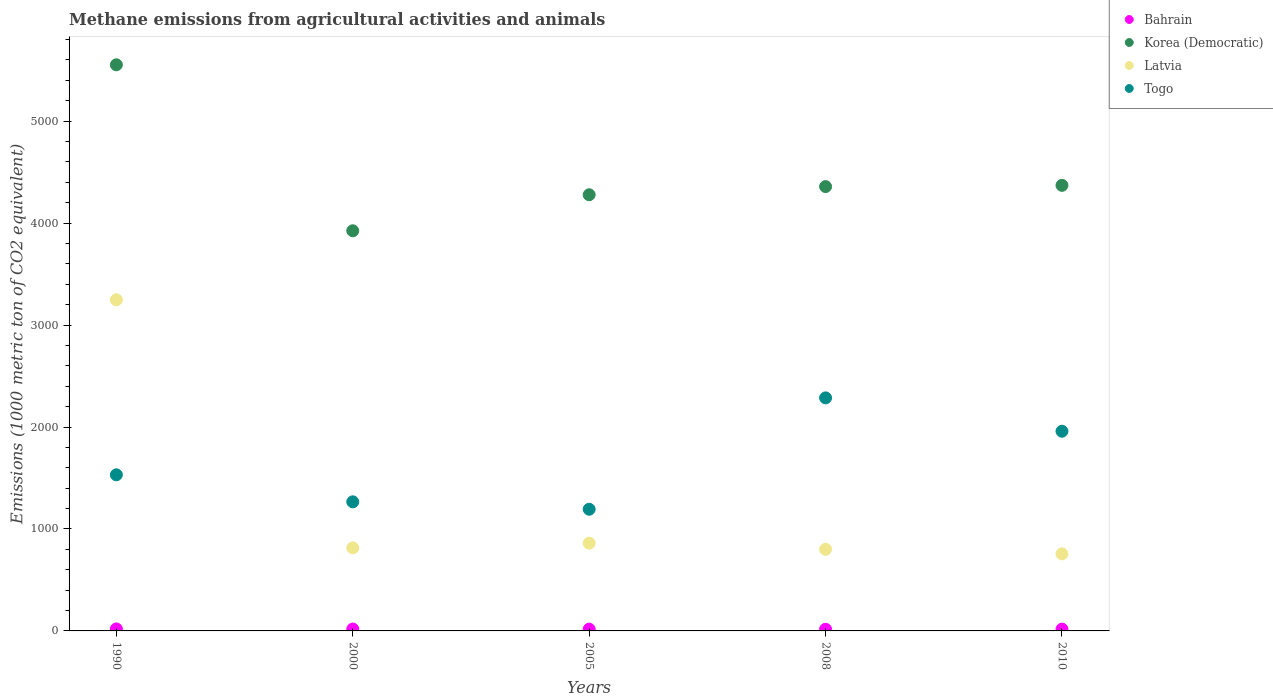How many different coloured dotlines are there?
Your answer should be compact. 4. What is the amount of methane emitted in Togo in 2005?
Offer a very short reply. 1193.3. Across all years, what is the maximum amount of methane emitted in Bahrain?
Make the answer very short. 19.5. Across all years, what is the minimum amount of methane emitted in Togo?
Ensure brevity in your answer.  1193.3. In which year was the amount of methane emitted in Bahrain maximum?
Offer a terse response. 1990. What is the total amount of methane emitted in Togo in the graph?
Your answer should be compact. 8234.7. What is the difference between the amount of methane emitted in Latvia in 1990 and that in 2000?
Provide a succinct answer. 2433.3. What is the difference between the amount of methane emitted in Latvia in 2008 and the amount of methane emitted in Togo in 2010?
Provide a short and direct response. -1157.7. What is the average amount of methane emitted in Togo per year?
Provide a short and direct response. 1646.94. In the year 2010, what is the difference between the amount of methane emitted in Latvia and amount of methane emitted in Togo?
Ensure brevity in your answer.  -1202.6. In how many years, is the amount of methane emitted in Togo greater than 4000 1000 metric ton?
Make the answer very short. 0. What is the ratio of the amount of methane emitted in Korea (Democratic) in 2000 to that in 2005?
Make the answer very short. 0.92. Is the amount of methane emitted in Korea (Democratic) in 2000 less than that in 2008?
Offer a very short reply. Yes. Is the difference between the amount of methane emitted in Latvia in 1990 and 2000 greater than the difference between the amount of methane emitted in Togo in 1990 and 2000?
Your response must be concise. Yes. What is the difference between the highest and the second highest amount of methane emitted in Latvia?
Make the answer very short. 2387.1. What is the difference between the highest and the lowest amount of methane emitted in Bahrain?
Make the answer very short. 3.3. Is the sum of the amount of methane emitted in Korea (Democratic) in 1990 and 2000 greater than the maximum amount of methane emitted in Bahrain across all years?
Offer a terse response. Yes. Does the amount of methane emitted in Korea (Democratic) monotonically increase over the years?
Offer a terse response. No. Is the amount of methane emitted in Togo strictly greater than the amount of methane emitted in Korea (Democratic) over the years?
Your answer should be compact. No. Is the amount of methane emitted in Togo strictly less than the amount of methane emitted in Bahrain over the years?
Provide a succinct answer. No. How many years are there in the graph?
Keep it short and to the point. 5. What is the difference between two consecutive major ticks on the Y-axis?
Your response must be concise. 1000. Does the graph contain any zero values?
Keep it short and to the point. No. Where does the legend appear in the graph?
Your answer should be very brief. Top right. How many legend labels are there?
Offer a very short reply. 4. What is the title of the graph?
Provide a succinct answer. Methane emissions from agricultural activities and animals. What is the label or title of the Y-axis?
Keep it short and to the point. Emissions (1000 metric ton of CO2 equivalent). What is the Emissions (1000 metric ton of CO2 equivalent) of Korea (Democratic) in 1990?
Keep it short and to the point. 5552.4. What is the Emissions (1000 metric ton of CO2 equivalent) of Latvia in 1990?
Keep it short and to the point. 3247.8. What is the Emissions (1000 metric ton of CO2 equivalent) of Togo in 1990?
Keep it short and to the point. 1531.1. What is the Emissions (1000 metric ton of CO2 equivalent) in Korea (Democratic) in 2000?
Provide a short and direct response. 3924.5. What is the Emissions (1000 metric ton of CO2 equivalent) of Latvia in 2000?
Make the answer very short. 814.5. What is the Emissions (1000 metric ton of CO2 equivalent) in Togo in 2000?
Your answer should be very brief. 1266.2. What is the Emissions (1000 metric ton of CO2 equivalent) in Bahrain in 2005?
Provide a succinct answer. 17.5. What is the Emissions (1000 metric ton of CO2 equivalent) of Korea (Democratic) in 2005?
Make the answer very short. 4277.9. What is the Emissions (1000 metric ton of CO2 equivalent) in Latvia in 2005?
Provide a short and direct response. 860.7. What is the Emissions (1000 metric ton of CO2 equivalent) in Togo in 2005?
Offer a terse response. 1193.3. What is the Emissions (1000 metric ton of CO2 equivalent) in Korea (Democratic) in 2008?
Offer a terse response. 4357.8. What is the Emissions (1000 metric ton of CO2 equivalent) in Latvia in 2008?
Keep it short and to the point. 800.8. What is the Emissions (1000 metric ton of CO2 equivalent) of Togo in 2008?
Offer a very short reply. 2285.6. What is the Emissions (1000 metric ton of CO2 equivalent) in Korea (Democratic) in 2010?
Keep it short and to the point. 4370.1. What is the Emissions (1000 metric ton of CO2 equivalent) in Latvia in 2010?
Ensure brevity in your answer.  755.9. What is the Emissions (1000 metric ton of CO2 equivalent) of Togo in 2010?
Ensure brevity in your answer.  1958.5. Across all years, what is the maximum Emissions (1000 metric ton of CO2 equivalent) of Bahrain?
Your answer should be very brief. 19.5. Across all years, what is the maximum Emissions (1000 metric ton of CO2 equivalent) of Korea (Democratic)?
Your answer should be very brief. 5552.4. Across all years, what is the maximum Emissions (1000 metric ton of CO2 equivalent) of Latvia?
Make the answer very short. 3247.8. Across all years, what is the maximum Emissions (1000 metric ton of CO2 equivalent) of Togo?
Provide a succinct answer. 2285.6. Across all years, what is the minimum Emissions (1000 metric ton of CO2 equivalent) of Bahrain?
Your answer should be compact. 16.2. Across all years, what is the minimum Emissions (1000 metric ton of CO2 equivalent) of Korea (Democratic)?
Your response must be concise. 3924.5. Across all years, what is the minimum Emissions (1000 metric ton of CO2 equivalent) of Latvia?
Offer a terse response. 755.9. Across all years, what is the minimum Emissions (1000 metric ton of CO2 equivalent) of Togo?
Provide a succinct answer. 1193.3. What is the total Emissions (1000 metric ton of CO2 equivalent) of Bahrain in the graph?
Offer a very short reply. 89.4. What is the total Emissions (1000 metric ton of CO2 equivalent) in Korea (Democratic) in the graph?
Your response must be concise. 2.25e+04. What is the total Emissions (1000 metric ton of CO2 equivalent) of Latvia in the graph?
Make the answer very short. 6479.7. What is the total Emissions (1000 metric ton of CO2 equivalent) of Togo in the graph?
Provide a succinct answer. 8234.7. What is the difference between the Emissions (1000 metric ton of CO2 equivalent) of Korea (Democratic) in 1990 and that in 2000?
Keep it short and to the point. 1627.9. What is the difference between the Emissions (1000 metric ton of CO2 equivalent) of Latvia in 1990 and that in 2000?
Your answer should be very brief. 2433.3. What is the difference between the Emissions (1000 metric ton of CO2 equivalent) of Togo in 1990 and that in 2000?
Ensure brevity in your answer.  264.9. What is the difference between the Emissions (1000 metric ton of CO2 equivalent) in Bahrain in 1990 and that in 2005?
Ensure brevity in your answer.  2. What is the difference between the Emissions (1000 metric ton of CO2 equivalent) of Korea (Democratic) in 1990 and that in 2005?
Your response must be concise. 1274.5. What is the difference between the Emissions (1000 metric ton of CO2 equivalent) in Latvia in 1990 and that in 2005?
Your answer should be compact. 2387.1. What is the difference between the Emissions (1000 metric ton of CO2 equivalent) in Togo in 1990 and that in 2005?
Your answer should be very brief. 337.8. What is the difference between the Emissions (1000 metric ton of CO2 equivalent) in Korea (Democratic) in 1990 and that in 2008?
Give a very brief answer. 1194.6. What is the difference between the Emissions (1000 metric ton of CO2 equivalent) of Latvia in 1990 and that in 2008?
Keep it short and to the point. 2447. What is the difference between the Emissions (1000 metric ton of CO2 equivalent) in Togo in 1990 and that in 2008?
Offer a very short reply. -754.5. What is the difference between the Emissions (1000 metric ton of CO2 equivalent) in Bahrain in 1990 and that in 2010?
Keep it short and to the point. 1.8. What is the difference between the Emissions (1000 metric ton of CO2 equivalent) in Korea (Democratic) in 1990 and that in 2010?
Your answer should be compact. 1182.3. What is the difference between the Emissions (1000 metric ton of CO2 equivalent) in Latvia in 1990 and that in 2010?
Keep it short and to the point. 2491.9. What is the difference between the Emissions (1000 metric ton of CO2 equivalent) of Togo in 1990 and that in 2010?
Your answer should be very brief. -427.4. What is the difference between the Emissions (1000 metric ton of CO2 equivalent) in Korea (Democratic) in 2000 and that in 2005?
Your answer should be very brief. -353.4. What is the difference between the Emissions (1000 metric ton of CO2 equivalent) in Latvia in 2000 and that in 2005?
Give a very brief answer. -46.2. What is the difference between the Emissions (1000 metric ton of CO2 equivalent) in Togo in 2000 and that in 2005?
Your answer should be very brief. 72.9. What is the difference between the Emissions (1000 metric ton of CO2 equivalent) of Bahrain in 2000 and that in 2008?
Provide a short and direct response. 2.3. What is the difference between the Emissions (1000 metric ton of CO2 equivalent) of Korea (Democratic) in 2000 and that in 2008?
Provide a succinct answer. -433.3. What is the difference between the Emissions (1000 metric ton of CO2 equivalent) in Togo in 2000 and that in 2008?
Offer a terse response. -1019.4. What is the difference between the Emissions (1000 metric ton of CO2 equivalent) of Bahrain in 2000 and that in 2010?
Ensure brevity in your answer.  0.8. What is the difference between the Emissions (1000 metric ton of CO2 equivalent) in Korea (Democratic) in 2000 and that in 2010?
Keep it short and to the point. -445.6. What is the difference between the Emissions (1000 metric ton of CO2 equivalent) of Latvia in 2000 and that in 2010?
Keep it short and to the point. 58.6. What is the difference between the Emissions (1000 metric ton of CO2 equivalent) in Togo in 2000 and that in 2010?
Keep it short and to the point. -692.3. What is the difference between the Emissions (1000 metric ton of CO2 equivalent) of Korea (Democratic) in 2005 and that in 2008?
Ensure brevity in your answer.  -79.9. What is the difference between the Emissions (1000 metric ton of CO2 equivalent) in Latvia in 2005 and that in 2008?
Your answer should be very brief. 59.9. What is the difference between the Emissions (1000 metric ton of CO2 equivalent) of Togo in 2005 and that in 2008?
Your answer should be compact. -1092.3. What is the difference between the Emissions (1000 metric ton of CO2 equivalent) in Bahrain in 2005 and that in 2010?
Your answer should be very brief. -0.2. What is the difference between the Emissions (1000 metric ton of CO2 equivalent) in Korea (Democratic) in 2005 and that in 2010?
Give a very brief answer. -92.2. What is the difference between the Emissions (1000 metric ton of CO2 equivalent) of Latvia in 2005 and that in 2010?
Give a very brief answer. 104.8. What is the difference between the Emissions (1000 metric ton of CO2 equivalent) of Togo in 2005 and that in 2010?
Provide a short and direct response. -765.2. What is the difference between the Emissions (1000 metric ton of CO2 equivalent) of Korea (Democratic) in 2008 and that in 2010?
Give a very brief answer. -12.3. What is the difference between the Emissions (1000 metric ton of CO2 equivalent) of Latvia in 2008 and that in 2010?
Offer a terse response. 44.9. What is the difference between the Emissions (1000 metric ton of CO2 equivalent) in Togo in 2008 and that in 2010?
Ensure brevity in your answer.  327.1. What is the difference between the Emissions (1000 metric ton of CO2 equivalent) of Bahrain in 1990 and the Emissions (1000 metric ton of CO2 equivalent) of Korea (Democratic) in 2000?
Ensure brevity in your answer.  -3905. What is the difference between the Emissions (1000 metric ton of CO2 equivalent) of Bahrain in 1990 and the Emissions (1000 metric ton of CO2 equivalent) of Latvia in 2000?
Make the answer very short. -795. What is the difference between the Emissions (1000 metric ton of CO2 equivalent) in Bahrain in 1990 and the Emissions (1000 metric ton of CO2 equivalent) in Togo in 2000?
Ensure brevity in your answer.  -1246.7. What is the difference between the Emissions (1000 metric ton of CO2 equivalent) in Korea (Democratic) in 1990 and the Emissions (1000 metric ton of CO2 equivalent) in Latvia in 2000?
Give a very brief answer. 4737.9. What is the difference between the Emissions (1000 metric ton of CO2 equivalent) of Korea (Democratic) in 1990 and the Emissions (1000 metric ton of CO2 equivalent) of Togo in 2000?
Keep it short and to the point. 4286.2. What is the difference between the Emissions (1000 metric ton of CO2 equivalent) in Latvia in 1990 and the Emissions (1000 metric ton of CO2 equivalent) in Togo in 2000?
Provide a short and direct response. 1981.6. What is the difference between the Emissions (1000 metric ton of CO2 equivalent) of Bahrain in 1990 and the Emissions (1000 metric ton of CO2 equivalent) of Korea (Democratic) in 2005?
Provide a succinct answer. -4258.4. What is the difference between the Emissions (1000 metric ton of CO2 equivalent) in Bahrain in 1990 and the Emissions (1000 metric ton of CO2 equivalent) in Latvia in 2005?
Your response must be concise. -841.2. What is the difference between the Emissions (1000 metric ton of CO2 equivalent) of Bahrain in 1990 and the Emissions (1000 metric ton of CO2 equivalent) of Togo in 2005?
Your answer should be very brief. -1173.8. What is the difference between the Emissions (1000 metric ton of CO2 equivalent) of Korea (Democratic) in 1990 and the Emissions (1000 metric ton of CO2 equivalent) of Latvia in 2005?
Your response must be concise. 4691.7. What is the difference between the Emissions (1000 metric ton of CO2 equivalent) of Korea (Democratic) in 1990 and the Emissions (1000 metric ton of CO2 equivalent) of Togo in 2005?
Provide a short and direct response. 4359.1. What is the difference between the Emissions (1000 metric ton of CO2 equivalent) in Latvia in 1990 and the Emissions (1000 metric ton of CO2 equivalent) in Togo in 2005?
Give a very brief answer. 2054.5. What is the difference between the Emissions (1000 metric ton of CO2 equivalent) in Bahrain in 1990 and the Emissions (1000 metric ton of CO2 equivalent) in Korea (Democratic) in 2008?
Your response must be concise. -4338.3. What is the difference between the Emissions (1000 metric ton of CO2 equivalent) in Bahrain in 1990 and the Emissions (1000 metric ton of CO2 equivalent) in Latvia in 2008?
Your answer should be compact. -781.3. What is the difference between the Emissions (1000 metric ton of CO2 equivalent) in Bahrain in 1990 and the Emissions (1000 metric ton of CO2 equivalent) in Togo in 2008?
Your answer should be very brief. -2266.1. What is the difference between the Emissions (1000 metric ton of CO2 equivalent) in Korea (Democratic) in 1990 and the Emissions (1000 metric ton of CO2 equivalent) in Latvia in 2008?
Ensure brevity in your answer.  4751.6. What is the difference between the Emissions (1000 metric ton of CO2 equivalent) of Korea (Democratic) in 1990 and the Emissions (1000 metric ton of CO2 equivalent) of Togo in 2008?
Provide a short and direct response. 3266.8. What is the difference between the Emissions (1000 metric ton of CO2 equivalent) of Latvia in 1990 and the Emissions (1000 metric ton of CO2 equivalent) of Togo in 2008?
Give a very brief answer. 962.2. What is the difference between the Emissions (1000 metric ton of CO2 equivalent) of Bahrain in 1990 and the Emissions (1000 metric ton of CO2 equivalent) of Korea (Democratic) in 2010?
Provide a succinct answer. -4350.6. What is the difference between the Emissions (1000 metric ton of CO2 equivalent) in Bahrain in 1990 and the Emissions (1000 metric ton of CO2 equivalent) in Latvia in 2010?
Provide a short and direct response. -736.4. What is the difference between the Emissions (1000 metric ton of CO2 equivalent) in Bahrain in 1990 and the Emissions (1000 metric ton of CO2 equivalent) in Togo in 2010?
Keep it short and to the point. -1939. What is the difference between the Emissions (1000 metric ton of CO2 equivalent) of Korea (Democratic) in 1990 and the Emissions (1000 metric ton of CO2 equivalent) of Latvia in 2010?
Your answer should be very brief. 4796.5. What is the difference between the Emissions (1000 metric ton of CO2 equivalent) of Korea (Democratic) in 1990 and the Emissions (1000 metric ton of CO2 equivalent) of Togo in 2010?
Make the answer very short. 3593.9. What is the difference between the Emissions (1000 metric ton of CO2 equivalent) of Latvia in 1990 and the Emissions (1000 metric ton of CO2 equivalent) of Togo in 2010?
Offer a very short reply. 1289.3. What is the difference between the Emissions (1000 metric ton of CO2 equivalent) in Bahrain in 2000 and the Emissions (1000 metric ton of CO2 equivalent) in Korea (Democratic) in 2005?
Provide a short and direct response. -4259.4. What is the difference between the Emissions (1000 metric ton of CO2 equivalent) of Bahrain in 2000 and the Emissions (1000 metric ton of CO2 equivalent) of Latvia in 2005?
Your response must be concise. -842.2. What is the difference between the Emissions (1000 metric ton of CO2 equivalent) of Bahrain in 2000 and the Emissions (1000 metric ton of CO2 equivalent) of Togo in 2005?
Ensure brevity in your answer.  -1174.8. What is the difference between the Emissions (1000 metric ton of CO2 equivalent) in Korea (Democratic) in 2000 and the Emissions (1000 metric ton of CO2 equivalent) in Latvia in 2005?
Ensure brevity in your answer.  3063.8. What is the difference between the Emissions (1000 metric ton of CO2 equivalent) in Korea (Democratic) in 2000 and the Emissions (1000 metric ton of CO2 equivalent) in Togo in 2005?
Offer a very short reply. 2731.2. What is the difference between the Emissions (1000 metric ton of CO2 equivalent) of Latvia in 2000 and the Emissions (1000 metric ton of CO2 equivalent) of Togo in 2005?
Offer a very short reply. -378.8. What is the difference between the Emissions (1000 metric ton of CO2 equivalent) of Bahrain in 2000 and the Emissions (1000 metric ton of CO2 equivalent) of Korea (Democratic) in 2008?
Provide a succinct answer. -4339.3. What is the difference between the Emissions (1000 metric ton of CO2 equivalent) of Bahrain in 2000 and the Emissions (1000 metric ton of CO2 equivalent) of Latvia in 2008?
Provide a succinct answer. -782.3. What is the difference between the Emissions (1000 metric ton of CO2 equivalent) of Bahrain in 2000 and the Emissions (1000 metric ton of CO2 equivalent) of Togo in 2008?
Give a very brief answer. -2267.1. What is the difference between the Emissions (1000 metric ton of CO2 equivalent) in Korea (Democratic) in 2000 and the Emissions (1000 metric ton of CO2 equivalent) in Latvia in 2008?
Make the answer very short. 3123.7. What is the difference between the Emissions (1000 metric ton of CO2 equivalent) in Korea (Democratic) in 2000 and the Emissions (1000 metric ton of CO2 equivalent) in Togo in 2008?
Give a very brief answer. 1638.9. What is the difference between the Emissions (1000 metric ton of CO2 equivalent) of Latvia in 2000 and the Emissions (1000 metric ton of CO2 equivalent) of Togo in 2008?
Your answer should be compact. -1471.1. What is the difference between the Emissions (1000 metric ton of CO2 equivalent) of Bahrain in 2000 and the Emissions (1000 metric ton of CO2 equivalent) of Korea (Democratic) in 2010?
Make the answer very short. -4351.6. What is the difference between the Emissions (1000 metric ton of CO2 equivalent) in Bahrain in 2000 and the Emissions (1000 metric ton of CO2 equivalent) in Latvia in 2010?
Offer a very short reply. -737.4. What is the difference between the Emissions (1000 metric ton of CO2 equivalent) in Bahrain in 2000 and the Emissions (1000 metric ton of CO2 equivalent) in Togo in 2010?
Your response must be concise. -1940. What is the difference between the Emissions (1000 metric ton of CO2 equivalent) of Korea (Democratic) in 2000 and the Emissions (1000 metric ton of CO2 equivalent) of Latvia in 2010?
Your response must be concise. 3168.6. What is the difference between the Emissions (1000 metric ton of CO2 equivalent) of Korea (Democratic) in 2000 and the Emissions (1000 metric ton of CO2 equivalent) of Togo in 2010?
Keep it short and to the point. 1966. What is the difference between the Emissions (1000 metric ton of CO2 equivalent) in Latvia in 2000 and the Emissions (1000 metric ton of CO2 equivalent) in Togo in 2010?
Give a very brief answer. -1144. What is the difference between the Emissions (1000 metric ton of CO2 equivalent) in Bahrain in 2005 and the Emissions (1000 metric ton of CO2 equivalent) in Korea (Democratic) in 2008?
Your answer should be very brief. -4340.3. What is the difference between the Emissions (1000 metric ton of CO2 equivalent) of Bahrain in 2005 and the Emissions (1000 metric ton of CO2 equivalent) of Latvia in 2008?
Provide a short and direct response. -783.3. What is the difference between the Emissions (1000 metric ton of CO2 equivalent) of Bahrain in 2005 and the Emissions (1000 metric ton of CO2 equivalent) of Togo in 2008?
Offer a very short reply. -2268.1. What is the difference between the Emissions (1000 metric ton of CO2 equivalent) of Korea (Democratic) in 2005 and the Emissions (1000 metric ton of CO2 equivalent) of Latvia in 2008?
Provide a succinct answer. 3477.1. What is the difference between the Emissions (1000 metric ton of CO2 equivalent) in Korea (Democratic) in 2005 and the Emissions (1000 metric ton of CO2 equivalent) in Togo in 2008?
Make the answer very short. 1992.3. What is the difference between the Emissions (1000 metric ton of CO2 equivalent) in Latvia in 2005 and the Emissions (1000 metric ton of CO2 equivalent) in Togo in 2008?
Your answer should be compact. -1424.9. What is the difference between the Emissions (1000 metric ton of CO2 equivalent) in Bahrain in 2005 and the Emissions (1000 metric ton of CO2 equivalent) in Korea (Democratic) in 2010?
Provide a short and direct response. -4352.6. What is the difference between the Emissions (1000 metric ton of CO2 equivalent) of Bahrain in 2005 and the Emissions (1000 metric ton of CO2 equivalent) of Latvia in 2010?
Your response must be concise. -738.4. What is the difference between the Emissions (1000 metric ton of CO2 equivalent) of Bahrain in 2005 and the Emissions (1000 metric ton of CO2 equivalent) of Togo in 2010?
Your answer should be compact. -1941. What is the difference between the Emissions (1000 metric ton of CO2 equivalent) of Korea (Democratic) in 2005 and the Emissions (1000 metric ton of CO2 equivalent) of Latvia in 2010?
Your answer should be compact. 3522. What is the difference between the Emissions (1000 metric ton of CO2 equivalent) in Korea (Democratic) in 2005 and the Emissions (1000 metric ton of CO2 equivalent) in Togo in 2010?
Provide a short and direct response. 2319.4. What is the difference between the Emissions (1000 metric ton of CO2 equivalent) in Latvia in 2005 and the Emissions (1000 metric ton of CO2 equivalent) in Togo in 2010?
Ensure brevity in your answer.  -1097.8. What is the difference between the Emissions (1000 metric ton of CO2 equivalent) of Bahrain in 2008 and the Emissions (1000 metric ton of CO2 equivalent) of Korea (Democratic) in 2010?
Your answer should be very brief. -4353.9. What is the difference between the Emissions (1000 metric ton of CO2 equivalent) of Bahrain in 2008 and the Emissions (1000 metric ton of CO2 equivalent) of Latvia in 2010?
Your response must be concise. -739.7. What is the difference between the Emissions (1000 metric ton of CO2 equivalent) in Bahrain in 2008 and the Emissions (1000 metric ton of CO2 equivalent) in Togo in 2010?
Offer a terse response. -1942.3. What is the difference between the Emissions (1000 metric ton of CO2 equivalent) of Korea (Democratic) in 2008 and the Emissions (1000 metric ton of CO2 equivalent) of Latvia in 2010?
Provide a succinct answer. 3601.9. What is the difference between the Emissions (1000 metric ton of CO2 equivalent) of Korea (Democratic) in 2008 and the Emissions (1000 metric ton of CO2 equivalent) of Togo in 2010?
Ensure brevity in your answer.  2399.3. What is the difference between the Emissions (1000 metric ton of CO2 equivalent) in Latvia in 2008 and the Emissions (1000 metric ton of CO2 equivalent) in Togo in 2010?
Make the answer very short. -1157.7. What is the average Emissions (1000 metric ton of CO2 equivalent) in Bahrain per year?
Offer a terse response. 17.88. What is the average Emissions (1000 metric ton of CO2 equivalent) of Korea (Democratic) per year?
Offer a very short reply. 4496.54. What is the average Emissions (1000 metric ton of CO2 equivalent) of Latvia per year?
Make the answer very short. 1295.94. What is the average Emissions (1000 metric ton of CO2 equivalent) of Togo per year?
Your answer should be very brief. 1646.94. In the year 1990, what is the difference between the Emissions (1000 metric ton of CO2 equivalent) of Bahrain and Emissions (1000 metric ton of CO2 equivalent) of Korea (Democratic)?
Ensure brevity in your answer.  -5532.9. In the year 1990, what is the difference between the Emissions (1000 metric ton of CO2 equivalent) of Bahrain and Emissions (1000 metric ton of CO2 equivalent) of Latvia?
Ensure brevity in your answer.  -3228.3. In the year 1990, what is the difference between the Emissions (1000 metric ton of CO2 equivalent) in Bahrain and Emissions (1000 metric ton of CO2 equivalent) in Togo?
Offer a terse response. -1511.6. In the year 1990, what is the difference between the Emissions (1000 metric ton of CO2 equivalent) of Korea (Democratic) and Emissions (1000 metric ton of CO2 equivalent) of Latvia?
Provide a short and direct response. 2304.6. In the year 1990, what is the difference between the Emissions (1000 metric ton of CO2 equivalent) of Korea (Democratic) and Emissions (1000 metric ton of CO2 equivalent) of Togo?
Provide a short and direct response. 4021.3. In the year 1990, what is the difference between the Emissions (1000 metric ton of CO2 equivalent) of Latvia and Emissions (1000 metric ton of CO2 equivalent) of Togo?
Keep it short and to the point. 1716.7. In the year 2000, what is the difference between the Emissions (1000 metric ton of CO2 equivalent) in Bahrain and Emissions (1000 metric ton of CO2 equivalent) in Korea (Democratic)?
Offer a terse response. -3906. In the year 2000, what is the difference between the Emissions (1000 metric ton of CO2 equivalent) of Bahrain and Emissions (1000 metric ton of CO2 equivalent) of Latvia?
Provide a succinct answer. -796. In the year 2000, what is the difference between the Emissions (1000 metric ton of CO2 equivalent) of Bahrain and Emissions (1000 metric ton of CO2 equivalent) of Togo?
Keep it short and to the point. -1247.7. In the year 2000, what is the difference between the Emissions (1000 metric ton of CO2 equivalent) of Korea (Democratic) and Emissions (1000 metric ton of CO2 equivalent) of Latvia?
Offer a terse response. 3110. In the year 2000, what is the difference between the Emissions (1000 metric ton of CO2 equivalent) in Korea (Democratic) and Emissions (1000 metric ton of CO2 equivalent) in Togo?
Make the answer very short. 2658.3. In the year 2000, what is the difference between the Emissions (1000 metric ton of CO2 equivalent) of Latvia and Emissions (1000 metric ton of CO2 equivalent) of Togo?
Ensure brevity in your answer.  -451.7. In the year 2005, what is the difference between the Emissions (1000 metric ton of CO2 equivalent) of Bahrain and Emissions (1000 metric ton of CO2 equivalent) of Korea (Democratic)?
Offer a terse response. -4260.4. In the year 2005, what is the difference between the Emissions (1000 metric ton of CO2 equivalent) of Bahrain and Emissions (1000 metric ton of CO2 equivalent) of Latvia?
Offer a terse response. -843.2. In the year 2005, what is the difference between the Emissions (1000 metric ton of CO2 equivalent) in Bahrain and Emissions (1000 metric ton of CO2 equivalent) in Togo?
Offer a very short reply. -1175.8. In the year 2005, what is the difference between the Emissions (1000 metric ton of CO2 equivalent) of Korea (Democratic) and Emissions (1000 metric ton of CO2 equivalent) of Latvia?
Provide a short and direct response. 3417.2. In the year 2005, what is the difference between the Emissions (1000 metric ton of CO2 equivalent) in Korea (Democratic) and Emissions (1000 metric ton of CO2 equivalent) in Togo?
Your answer should be compact. 3084.6. In the year 2005, what is the difference between the Emissions (1000 metric ton of CO2 equivalent) of Latvia and Emissions (1000 metric ton of CO2 equivalent) of Togo?
Provide a short and direct response. -332.6. In the year 2008, what is the difference between the Emissions (1000 metric ton of CO2 equivalent) in Bahrain and Emissions (1000 metric ton of CO2 equivalent) in Korea (Democratic)?
Provide a short and direct response. -4341.6. In the year 2008, what is the difference between the Emissions (1000 metric ton of CO2 equivalent) of Bahrain and Emissions (1000 metric ton of CO2 equivalent) of Latvia?
Keep it short and to the point. -784.6. In the year 2008, what is the difference between the Emissions (1000 metric ton of CO2 equivalent) in Bahrain and Emissions (1000 metric ton of CO2 equivalent) in Togo?
Provide a short and direct response. -2269.4. In the year 2008, what is the difference between the Emissions (1000 metric ton of CO2 equivalent) in Korea (Democratic) and Emissions (1000 metric ton of CO2 equivalent) in Latvia?
Your response must be concise. 3557. In the year 2008, what is the difference between the Emissions (1000 metric ton of CO2 equivalent) in Korea (Democratic) and Emissions (1000 metric ton of CO2 equivalent) in Togo?
Offer a very short reply. 2072.2. In the year 2008, what is the difference between the Emissions (1000 metric ton of CO2 equivalent) of Latvia and Emissions (1000 metric ton of CO2 equivalent) of Togo?
Your response must be concise. -1484.8. In the year 2010, what is the difference between the Emissions (1000 metric ton of CO2 equivalent) in Bahrain and Emissions (1000 metric ton of CO2 equivalent) in Korea (Democratic)?
Your response must be concise. -4352.4. In the year 2010, what is the difference between the Emissions (1000 metric ton of CO2 equivalent) of Bahrain and Emissions (1000 metric ton of CO2 equivalent) of Latvia?
Offer a very short reply. -738.2. In the year 2010, what is the difference between the Emissions (1000 metric ton of CO2 equivalent) in Bahrain and Emissions (1000 metric ton of CO2 equivalent) in Togo?
Your answer should be very brief. -1940.8. In the year 2010, what is the difference between the Emissions (1000 metric ton of CO2 equivalent) of Korea (Democratic) and Emissions (1000 metric ton of CO2 equivalent) of Latvia?
Provide a succinct answer. 3614.2. In the year 2010, what is the difference between the Emissions (1000 metric ton of CO2 equivalent) in Korea (Democratic) and Emissions (1000 metric ton of CO2 equivalent) in Togo?
Offer a terse response. 2411.6. In the year 2010, what is the difference between the Emissions (1000 metric ton of CO2 equivalent) of Latvia and Emissions (1000 metric ton of CO2 equivalent) of Togo?
Make the answer very short. -1202.6. What is the ratio of the Emissions (1000 metric ton of CO2 equivalent) of Bahrain in 1990 to that in 2000?
Offer a very short reply. 1.05. What is the ratio of the Emissions (1000 metric ton of CO2 equivalent) in Korea (Democratic) in 1990 to that in 2000?
Keep it short and to the point. 1.41. What is the ratio of the Emissions (1000 metric ton of CO2 equivalent) of Latvia in 1990 to that in 2000?
Provide a succinct answer. 3.99. What is the ratio of the Emissions (1000 metric ton of CO2 equivalent) in Togo in 1990 to that in 2000?
Give a very brief answer. 1.21. What is the ratio of the Emissions (1000 metric ton of CO2 equivalent) in Bahrain in 1990 to that in 2005?
Give a very brief answer. 1.11. What is the ratio of the Emissions (1000 metric ton of CO2 equivalent) of Korea (Democratic) in 1990 to that in 2005?
Make the answer very short. 1.3. What is the ratio of the Emissions (1000 metric ton of CO2 equivalent) of Latvia in 1990 to that in 2005?
Make the answer very short. 3.77. What is the ratio of the Emissions (1000 metric ton of CO2 equivalent) in Togo in 1990 to that in 2005?
Ensure brevity in your answer.  1.28. What is the ratio of the Emissions (1000 metric ton of CO2 equivalent) of Bahrain in 1990 to that in 2008?
Make the answer very short. 1.2. What is the ratio of the Emissions (1000 metric ton of CO2 equivalent) of Korea (Democratic) in 1990 to that in 2008?
Provide a succinct answer. 1.27. What is the ratio of the Emissions (1000 metric ton of CO2 equivalent) in Latvia in 1990 to that in 2008?
Keep it short and to the point. 4.06. What is the ratio of the Emissions (1000 metric ton of CO2 equivalent) of Togo in 1990 to that in 2008?
Your answer should be very brief. 0.67. What is the ratio of the Emissions (1000 metric ton of CO2 equivalent) in Bahrain in 1990 to that in 2010?
Your response must be concise. 1.1. What is the ratio of the Emissions (1000 metric ton of CO2 equivalent) in Korea (Democratic) in 1990 to that in 2010?
Your response must be concise. 1.27. What is the ratio of the Emissions (1000 metric ton of CO2 equivalent) of Latvia in 1990 to that in 2010?
Give a very brief answer. 4.3. What is the ratio of the Emissions (1000 metric ton of CO2 equivalent) of Togo in 1990 to that in 2010?
Provide a short and direct response. 0.78. What is the ratio of the Emissions (1000 metric ton of CO2 equivalent) in Bahrain in 2000 to that in 2005?
Provide a succinct answer. 1.06. What is the ratio of the Emissions (1000 metric ton of CO2 equivalent) of Korea (Democratic) in 2000 to that in 2005?
Keep it short and to the point. 0.92. What is the ratio of the Emissions (1000 metric ton of CO2 equivalent) in Latvia in 2000 to that in 2005?
Provide a succinct answer. 0.95. What is the ratio of the Emissions (1000 metric ton of CO2 equivalent) of Togo in 2000 to that in 2005?
Your response must be concise. 1.06. What is the ratio of the Emissions (1000 metric ton of CO2 equivalent) in Bahrain in 2000 to that in 2008?
Keep it short and to the point. 1.14. What is the ratio of the Emissions (1000 metric ton of CO2 equivalent) of Korea (Democratic) in 2000 to that in 2008?
Keep it short and to the point. 0.9. What is the ratio of the Emissions (1000 metric ton of CO2 equivalent) of Latvia in 2000 to that in 2008?
Offer a very short reply. 1.02. What is the ratio of the Emissions (1000 metric ton of CO2 equivalent) in Togo in 2000 to that in 2008?
Provide a succinct answer. 0.55. What is the ratio of the Emissions (1000 metric ton of CO2 equivalent) in Bahrain in 2000 to that in 2010?
Keep it short and to the point. 1.05. What is the ratio of the Emissions (1000 metric ton of CO2 equivalent) of Korea (Democratic) in 2000 to that in 2010?
Your answer should be compact. 0.9. What is the ratio of the Emissions (1000 metric ton of CO2 equivalent) in Latvia in 2000 to that in 2010?
Keep it short and to the point. 1.08. What is the ratio of the Emissions (1000 metric ton of CO2 equivalent) of Togo in 2000 to that in 2010?
Offer a terse response. 0.65. What is the ratio of the Emissions (1000 metric ton of CO2 equivalent) in Bahrain in 2005 to that in 2008?
Offer a very short reply. 1.08. What is the ratio of the Emissions (1000 metric ton of CO2 equivalent) of Korea (Democratic) in 2005 to that in 2008?
Your response must be concise. 0.98. What is the ratio of the Emissions (1000 metric ton of CO2 equivalent) in Latvia in 2005 to that in 2008?
Your answer should be compact. 1.07. What is the ratio of the Emissions (1000 metric ton of CO2 equivalent) in Togo in 2005 to that in 2008?
Provide a short and direct response. 0.52. What is the ratio of the Emissions (1000 metric ton of CO2 equivalent) of Bahrain in 2005 to that in 2010?
Provide a succinct answer. 0.99. What is the ratio of the Emissions (1000 metric ton of CO2 equivalent) in Korea (Democratic) in 2005 to that in 2010?
Make the answer very short. 0.98. What is the ratio of the Emissions (1000 metric ton of CO2 equivalent) of Latvia in 2005 to that in 2010?
Offer a very short reply. 1.14. What is the ratio of the Emissions (1000 metric ton of CO2 equivalent) in Togo in 2005 to that in 2010?
Provide a short and direct response. 0.61. What is the ratio of the Emissions (1000 metric ton of CO2 equivalent) in Bahrain in 2008 to that in 2010?
Make the answer very short. 0.92. What is the ratio of the Emissions (1000 metric ton of CO2 equivalent) in Latvia in 2008 to that in 2010?
Your answer should be very brief. 1.06. What is the ratio of the Emissions (1000 metric ton of CO2 equivalent) of Togo in 2008 to that in 2010?
Your response must be concise. 1.17. What is the difference between the highest and the second highest Emissions (1000 metric ton of CO2 equivalent) in Korea (Democratic)?
Provide a succinct answer. 1182.3. What is the difference between the highest and the second highest Emissions (1000 metric ton of CO2 equivalent) in Latvia?
Your answer should be compact. 2387.1. What is the difference between the highest and the second highest Emissions (1000 metric ton of CO2 equivalent) in Togo?
Ensure brevity in your answer.  327.1. What is the difference between the highest and the lowest Emissions (1000 metric ton of CO2 equivalent) in Bahrain?
Offer a terse response. 3.3. What is the difference between the highest and the lowest Emissions (1000 metric ton of CO2 equivalent) of Korea (Democratic)?
Keep it short and to the point. 1627.9. What is the difference between the highest and the lowest Emissions (1000 metric ton of CO2 equivalent) of Latvia?
Make the answer very short. 2491.9. What is the difference between the highest and the lowest Emissions (1000 metric ton of CO2 equivalent) of Togo?
Offer a very short reply. 1092.3. 